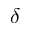<formula> <loc_0><loc_0><loc_500><loc_500>\delta</formula> 